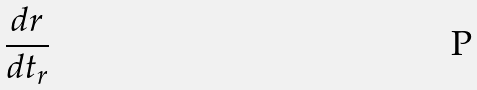Convert formula to latex. <formula><loc_0><loc_0><loc_500><loc_500>\frac { d r } { d t _ { r } }</formula> 